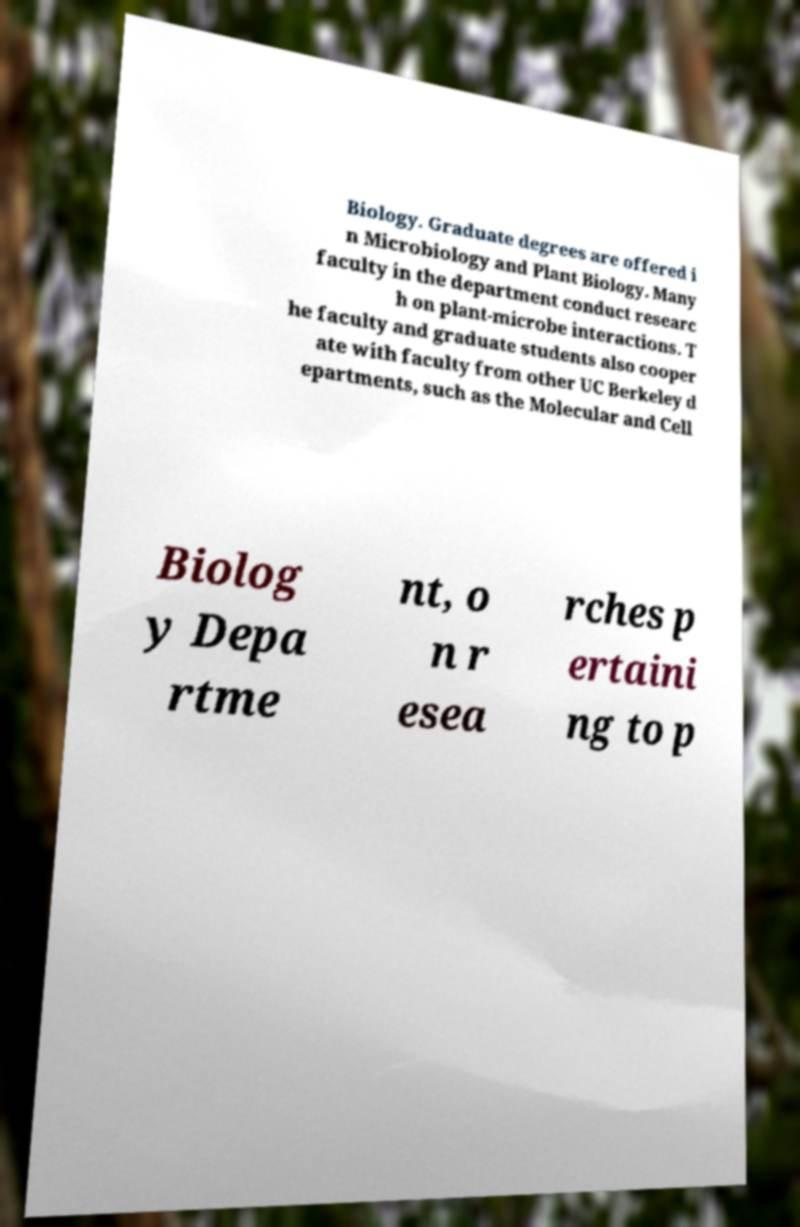What messages or text are displayed in this image? I need them in a readable, typed format. Biology. Graduate degrees are offered i n Microbiology and Plant Biology. Many faculty in the department conduct researc h on plant-microbe interactions. T he faculty and graduate students also cooper ate with faculty from other UC Berkeley d epartments, such as the Molecular and Cell Biolog y Depa rtme nt, o n r esea rches p ertaini ng to p 